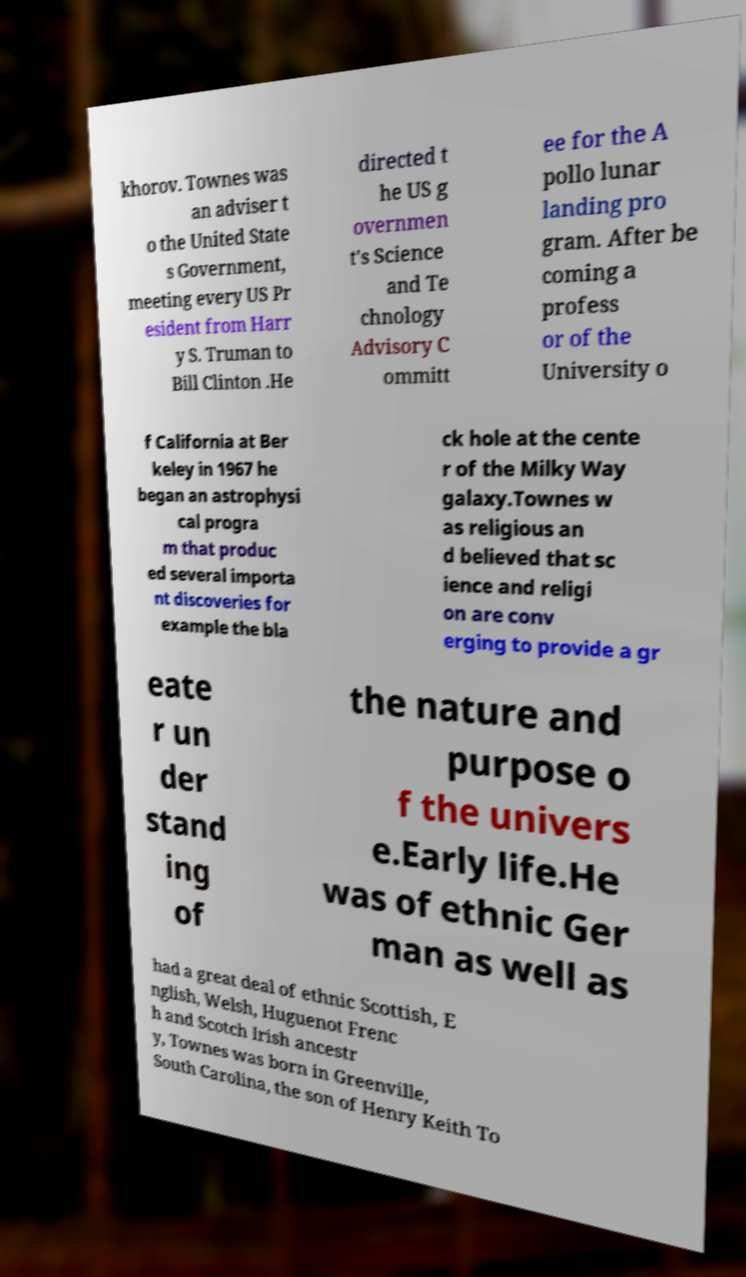Please read and relay the text visible in this image. What does it say? khorov. Townes was an adviser t o the United State s Government, meeting every US Pr esident from Harr y S. Truman to Bill Clinton .He directed t he US g overnmen t's Science and Te chnology Advisory C ommitt ee for the A pollo lunar landing pro gram. After be coming a profess or of the University o f California at Ber keley in 1967 he began an astrophysi cal progra m that produc ed several importa nt discoveries for example the bla ck hole at the cente r of the Milky Way galaxy.Townes w as religious an d believed that sc ience and religi on are conv erging to provide a gr eate r un der stand ing of the nature and purpose o f the univers e.Early life.He was of ethnic Ger man as well as had a great deal of ethnic Scottish, E nglish, Welsh, Huguenot Frenc h and Scotch Irish ancestr y, Townes was born in Greenville, South Carolina, the son of Henry Keith To 